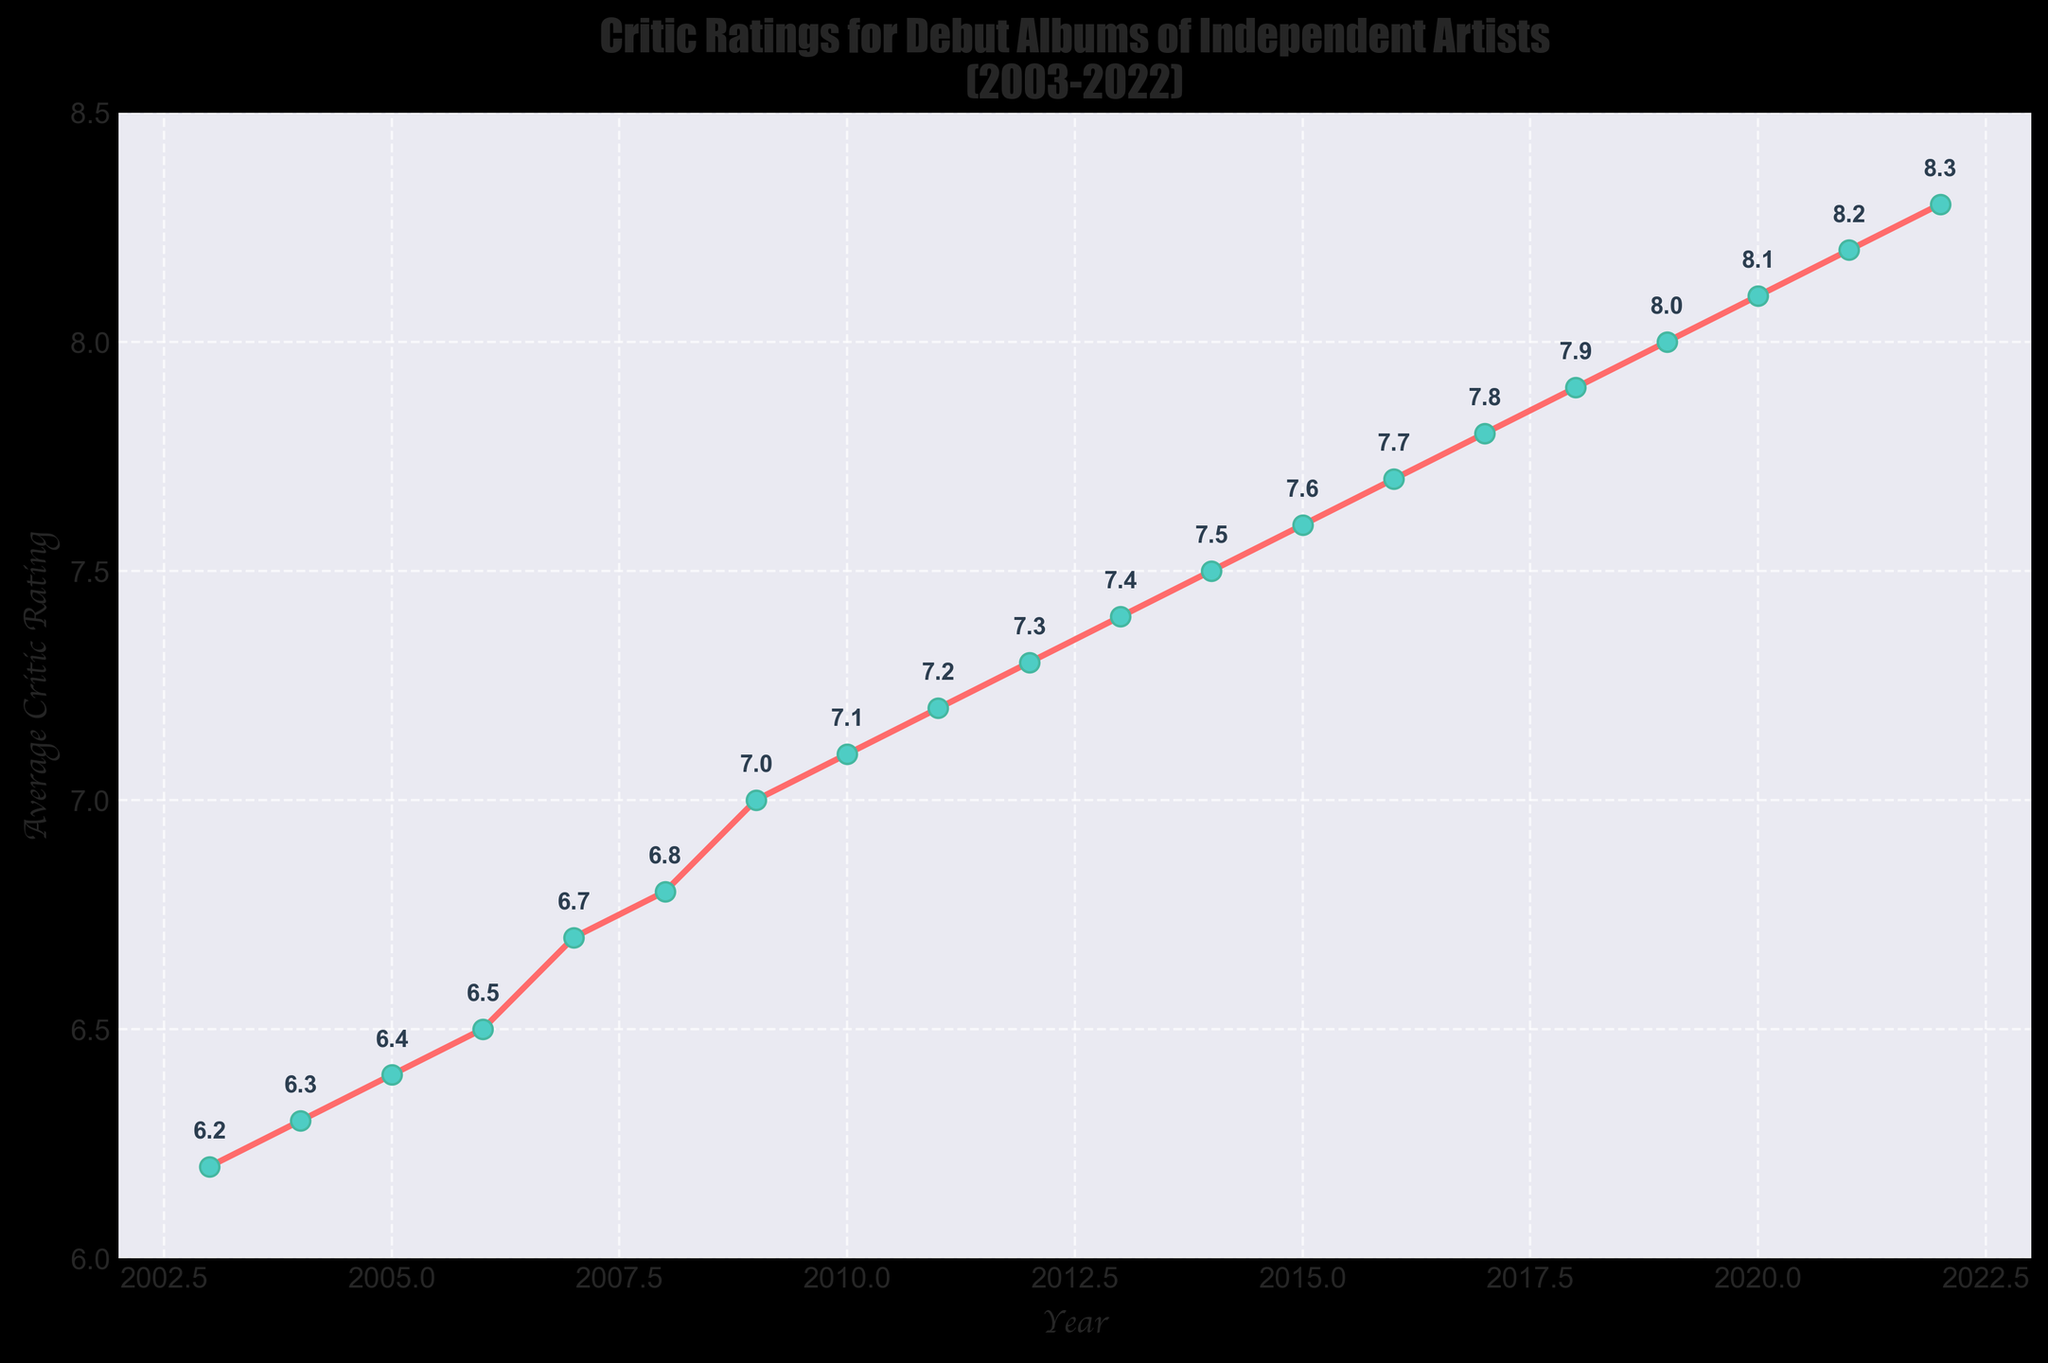what is the highest average critic rating in the dataset? The highest average critic rating can be found by identifying the peak value on the y-axis. The highest point on the chart corresponds to the year 2022 with a rating of 8.3.
Answer: 8.3 which year witnessed the greatest increase in average critic rating compared to the previous year? The greatest increase can be determined by looking at the year-to-year differences. From 2008 to 2009, the rating increased from 6.8 to 7.0, which is a 0.2 increase. Then, comparing all other increases, the year 2018 to 2019 had an increase of 0.1 (7.9 to 8.0), which is less. So, the greatest increase was from 2008 to 2009.
Answer: 2009 How much has the average critic rating improved from 2003 to 2022? To find the improvement, subtract the average critic rating in 2003 from the rating in 2022. The rating in 2003 is 6.2 and in 2022 is 8.3. So, the improvement is 8.3 - 6.2 = 2.1.
Answer: 2.1 What is the general trend of the average critic ratings over the years? By observing the slope of the line, the trend is noticeable. The line consistently moves upward from 2003 to 2022, indicating a steady improvement in average critic ratings.
Answer: Increasing Did any year have a decrease in average critic rating compared to the previous year? To determine if there's any decrease, examine the slope between each pair of consecutive years. The chart shows a consistent upward trend without any downward slopes, meaning there was no decrease.
Answer: No how many years had an average critic rating of 7 or higher? Count the number of years where the average critic rating is 7 or above. The years matching this criterion are from 2009 to 2022. This is 14 years in total.
Answer: 14 around which year did the average critic rating first reach 7.5? Locate the year on the x-axis where the y-axis value first hits 7.5. This was first achieved in 2014.
Answer: 2014 what visual element is used to represent the data points for each year? The data points for each year are represented by circular markers on the line.
Answer: Circular markers is the rate of increase in average critic ratings consistent across the years? The rate of increase can be assessed by observing the steepness of the line segments connecting the data points. The segments vary slightly in steepness but generally exhibit a consistent upward trend.
Answer: Generally consistent which two consecutive years exhibit the smallest difference in average critic rating? To find the smallest difference, examine the gap between each pair of consecutive years. The smallest difference is between 2017 (7.8) and 2018 (7.9), which is 0.1.
Answer: 2017-2018 